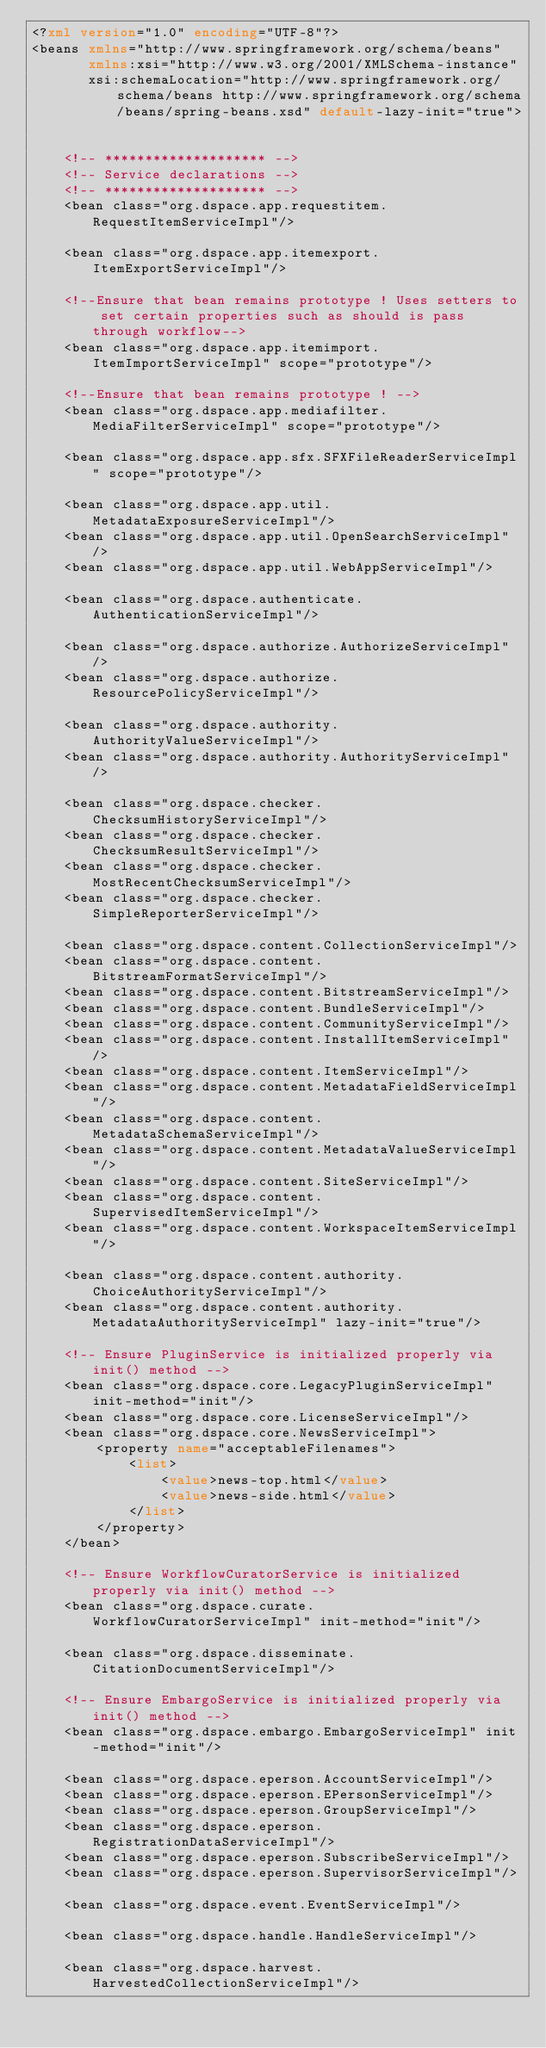Convert code to text. <code><loc_0><loc_0><loc_500><loc_500><_XML_><?xml version="1.0" encoding="UTF-8"?>
<beans xmlns="http://www.springframework.org/schema/beans"
       xmlns:xsi="http://www.w3.org/2001/XMLSchema-instance"
       xsi:schemaLocation="http://www.springframework.org/schema/beans http://www.springframework.org/schema/beans/spring-beans.xsd" default-lazy-init="true">


    <!-- ******************** -->
    <!-- Service declarations -->
    <!-- ******************** -->
    <bean class="org.dspace.app.requestitem.RequestItemServiceImpl"/>

    <bean class="org.dspace.app.itemexport.ItemExportServiceImpl"/>

    <!--Ensure that bean remains prototype ! Uses setters to set certain properties such as should is pass through workflow-->
    <bean class="org.dspace.app.itemimport.ItemImportServiceImpl" scope="prototype"/>

    <!--Ensure that bean remains prototype ! -->
    <bean class="org.dspace.app.mediafilter.MediaFilterServiceImpl" scope="prototype"/>

    <bean class="org.dspace.app.sfx.SFXFileReaderServiceImpl" scope="prototype"/>

    <bean class="org.dspace.app.util.MetadataExposureServiceImpl"/>
    <bean class="org.dspace.app.util.OpenSearchServiceImpl"/>
    <bean class="org.dspace.app.util.WebAppServiceImpl"/>

    <bean class="org.dspace.authenticate.AuthenticationServiceImpl"/>

    <bean class="org.dspace.authorize.AuthorizeServiceImpl"/>
    <bean class="org.dspace.authorize.ResourcePolicyServiceImpl"/>

    <bean class="org.dspace.authority.AuthorityValueServiceImpl"/>
    <bean class="org.dspace.authority.AuthorityServiceImpl"/>

    <bean class="org.dspace.checker.ChecksumHistoryServiceImpl"/>
    <bean class="org.dspace.checker.ChecksumResultServiceImpl"/>
    <bean class="org.dspace.checker.MostRecentChecksumServiceImpl"/>
    <bean class="org.dspace.checker.SimpleReporterServiceImpl"/>

    <bean class="org.dspace.content.CollectionServiceImpl"/>
    <bean class="org.dspace.content.BitstreamFormatServiceImpl"/>
    <bean class="org.dspace.content.BitstreamServiceImpl"/>
    <bean class="org.dspace.content.BundleServiceImpl"/>
    <bean class="org.dspace.content.CommunityServiceImpl"/>
    <bean class="org.dspace.content.InstallItemServiceImpl"/>
    <bean class="org.dspace.content.ItemServiceImpl"/>
    <bean class="org.dspace.content.MetadataFieldServiceImpl"/>
    <bean class="org.dspace.content.MetadataSchemaServiceImpl"/>
    <bean class="org.dspace.content.MetadataValueServiceImpl"/>
    <bean class="org.dspace.content.SiteServiceImpl"/>
    <bean class="org.dspace.content.SupervisedItemServiceImpl"/>
    <bean class="org.dspace.content.WorkspaceItemServiceImpl"/>

    <bean class="org.dspace.content.authority.ChoiceAuthorityServiceImpl"/>
    <bean class="org.dspace.content.authority.MetadataAuthorityServiceImpl" lazy-init="true"/>

    <!-- Ensure PluginService is initialized properly via init() method -->
    <bean class="org.dspace.core.LegacyPluginServiceImpl" init-method="init"/>
    <bean class="org.dspace.core.LicenseServiceImpl"/>
    <bean class="org.dspace.core.NewsServiceImpl">
   		<property name="acceptableFilenames">
			<list>
				<value>news-top.html</value>
				<value>news-side.html</value>
			</list>
		</property>
	</bean>

    <!-- Ensure WorkflowCuratorService is initialized properly via init() method -->
    <bean class="org.dspace.curate.WorkflowCuratorServiceImpl" init-method="init"/>

    <bean class="org.dspace.disseminate.CitationDocumentServiceImpl"/>

    <!-- Ensure EmbargoService is initialized properly via init() method -->
    <bean class="org.dspace.embargo.EmbargoServiceImpl" init-method="init"/>

    <bean class="org.dspace.eperson.AccountServiceImpl"/>
    <bean class="org.dspace.eperson.EPersonServiceImpl"/>
    <bean class="org.dspace.eperson.GroupServiceImpl"/>
    <bean class="org.dspace.eperson.RegistrationDataServiceImpl"/>
    <bean class="org.dspace.eperson.SubscribeServiceImpl"/>
    <bean class="org.dspace.eperson.SupervisorServiceImpl"/>

    <bean class="org.dspace.event.EventServiceImpl"/>

    <bean class="org.dspace.handle.HandleServiceImpl"/>

    <bean class="org.dspace.harvest.HarvestedCollectionServiceImpl"/></code> 